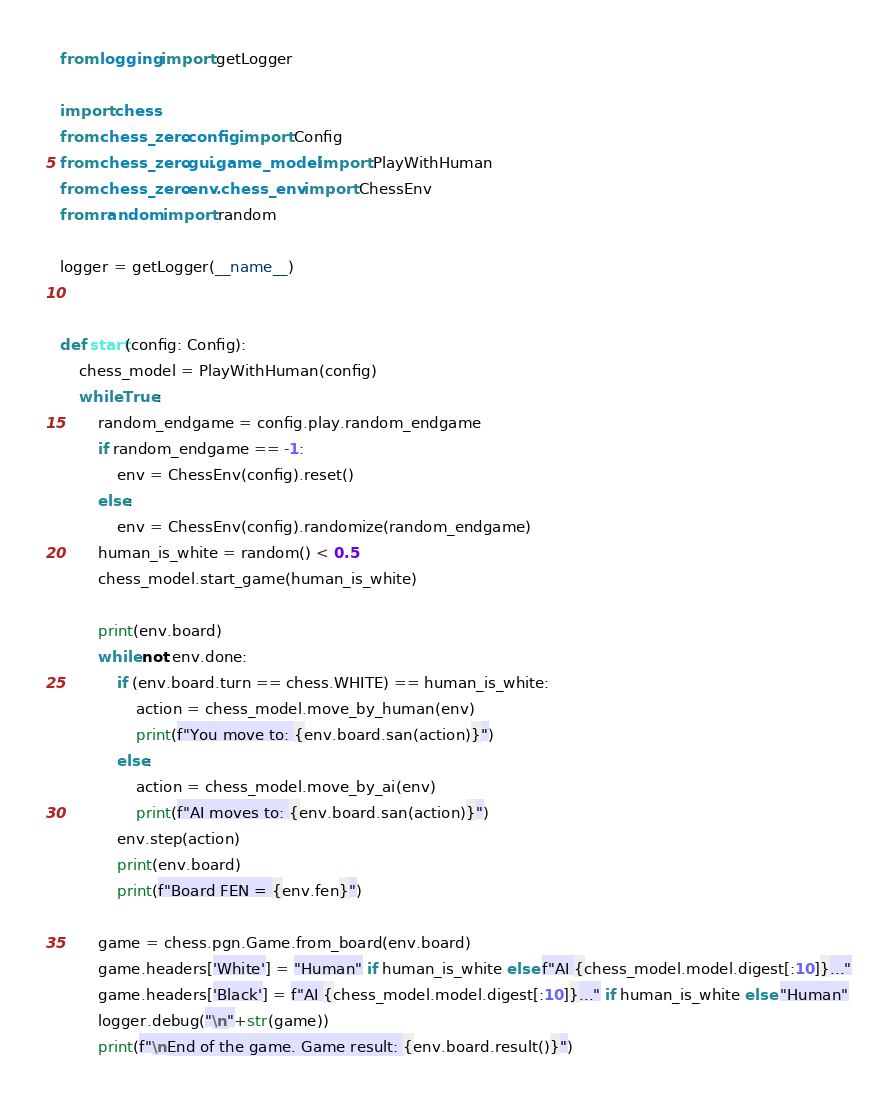<code> <loc_0><loc_0><loc_500><loc_500><_Python_>from logging import getLogger

import chess
from chess_zero.config import Config
from chess_zero.gui.game_model import PlayWithHuman
from chess_zero.env.chess_env import ChessEnv
from random import random

logger = getLogger(__name__)


def start(config: Config):
    chess_model = PlayWithHuman(config)
    while True:
        random_endgame = config.play.random_endgame
        if random_endgame == -1:
            env = ChessEnv(config).reset()
        else:
            env = ChessEnv(config).randomize(random_endgame)
        human_is_white = random() < 0.5
        chess_model.start_game(human_is_white)

        print(env.board)
        while not env.done:
            if (env.board.turn == chess.WHITE) == human_is_white:
                action = chess_model.move_by_human(env)
                print(f"You move to: {env.board.san(action)}")
            else:
                action = chess_model.move_by_ai(env)
                print(f"AI moves to: {env.board.san(action)}")
            env.step(action)
            print(env.board)
            print(f"Board FEN = {env.fen}")

        game = chess.pgn.Game.from_board(env.board)
        game.headers['White'] = "Human" if human_is_white else f"AI {chess_model.model.digest[:10]}..."
        game.headers['Black'] = f"AI {chess_model.model.digest[:10]}..." if human_is_white else "Human"
        logger.debug("\n"+str(game))
        print(f"\nEnd of the game. Game result: {env.board.result()}")
</code> 